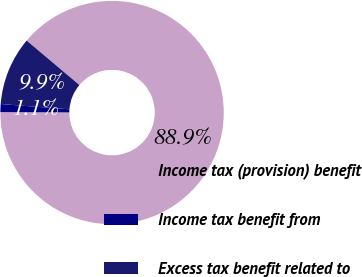Convert chart to OTSL. <chart><loc_0><loc_0><loc_500><loc_500><pie_chart><fcel>Income tax (provision) benefit<fcel>Income tax benefit from<fcel>Excess tax benefit related to<nl><fcel>88.93%<fcel>1.15%<fcel>9.93%<nl></chart> 